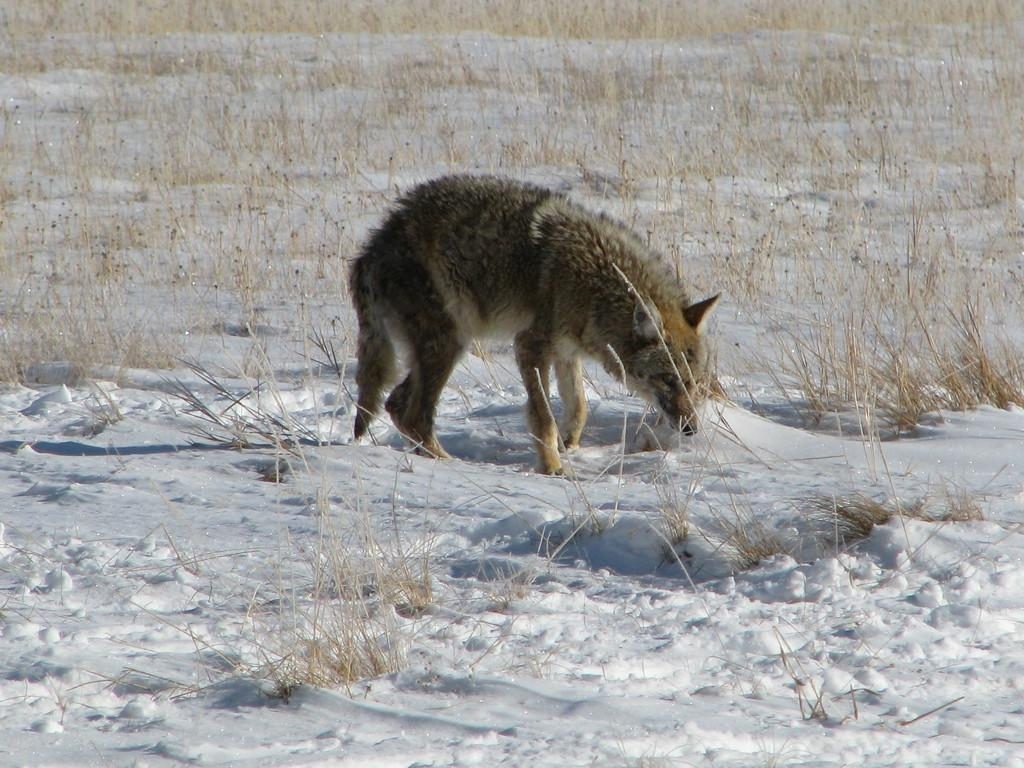What animal is present in the image? There is a wolf in the image. What is the wolf standing on? The wolf is on the snow. What type of vegetation can be seen at the bottom of the image? There is grass at the bottom of the image. How is the grass situated in the image? The grass is on the surface. What type of glass is being used as a seat by the wolf in the image? There is no glass or seat present in the image; the wolf is standing on snow. 